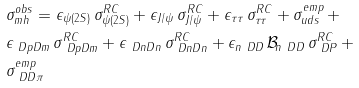Convert formula to latex. <formula><loc_0><loc_0><loc_500><loc_500>& \sigma ^ { o b s } _ { m h } = \epsilon _ { \psi ( 2 S ) } \, \sigma ^ { R C } _ { \psi ( 2 S ) } + \epsilon _ { J / \psi } \, \sigma ^ { R C } _ { J / \psi } + \epsilon _ { \tau \tau } \, \sigma ^ { R C } _ { \tau \tau } + \sigma ^ { e m p } _ { u d s } \, + \\ & \epsilon _ { \ D p D m } \, \sigma ^ { R C } _ { \ D p D m } + \epsilon _ { \ D n D n } \, \sigma ^ { R C } _ { \ D n D n } + \epsilon _ { n \ D D } \, \mathcal { B } _ { n \ D D } \, \sigma ^ { R C } _ { \ D P } \, + \\ & \sigma ^ { e m p } _ { \ D D \pi }</formula> 